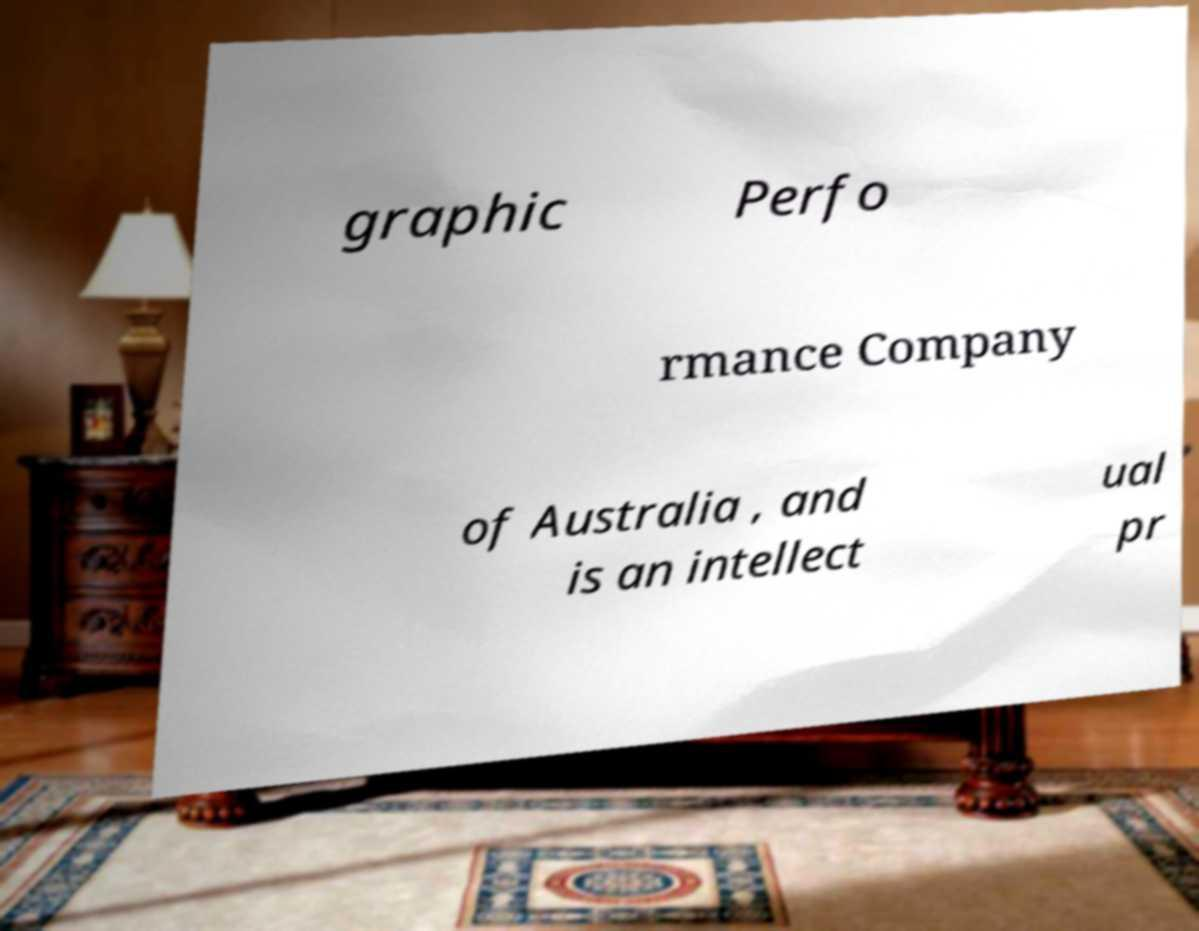For documentation purposes, I need the text within this image transcribed. Could you provide that? graphic Perfo rmance Company of Australia , and is an intellect ual pr 